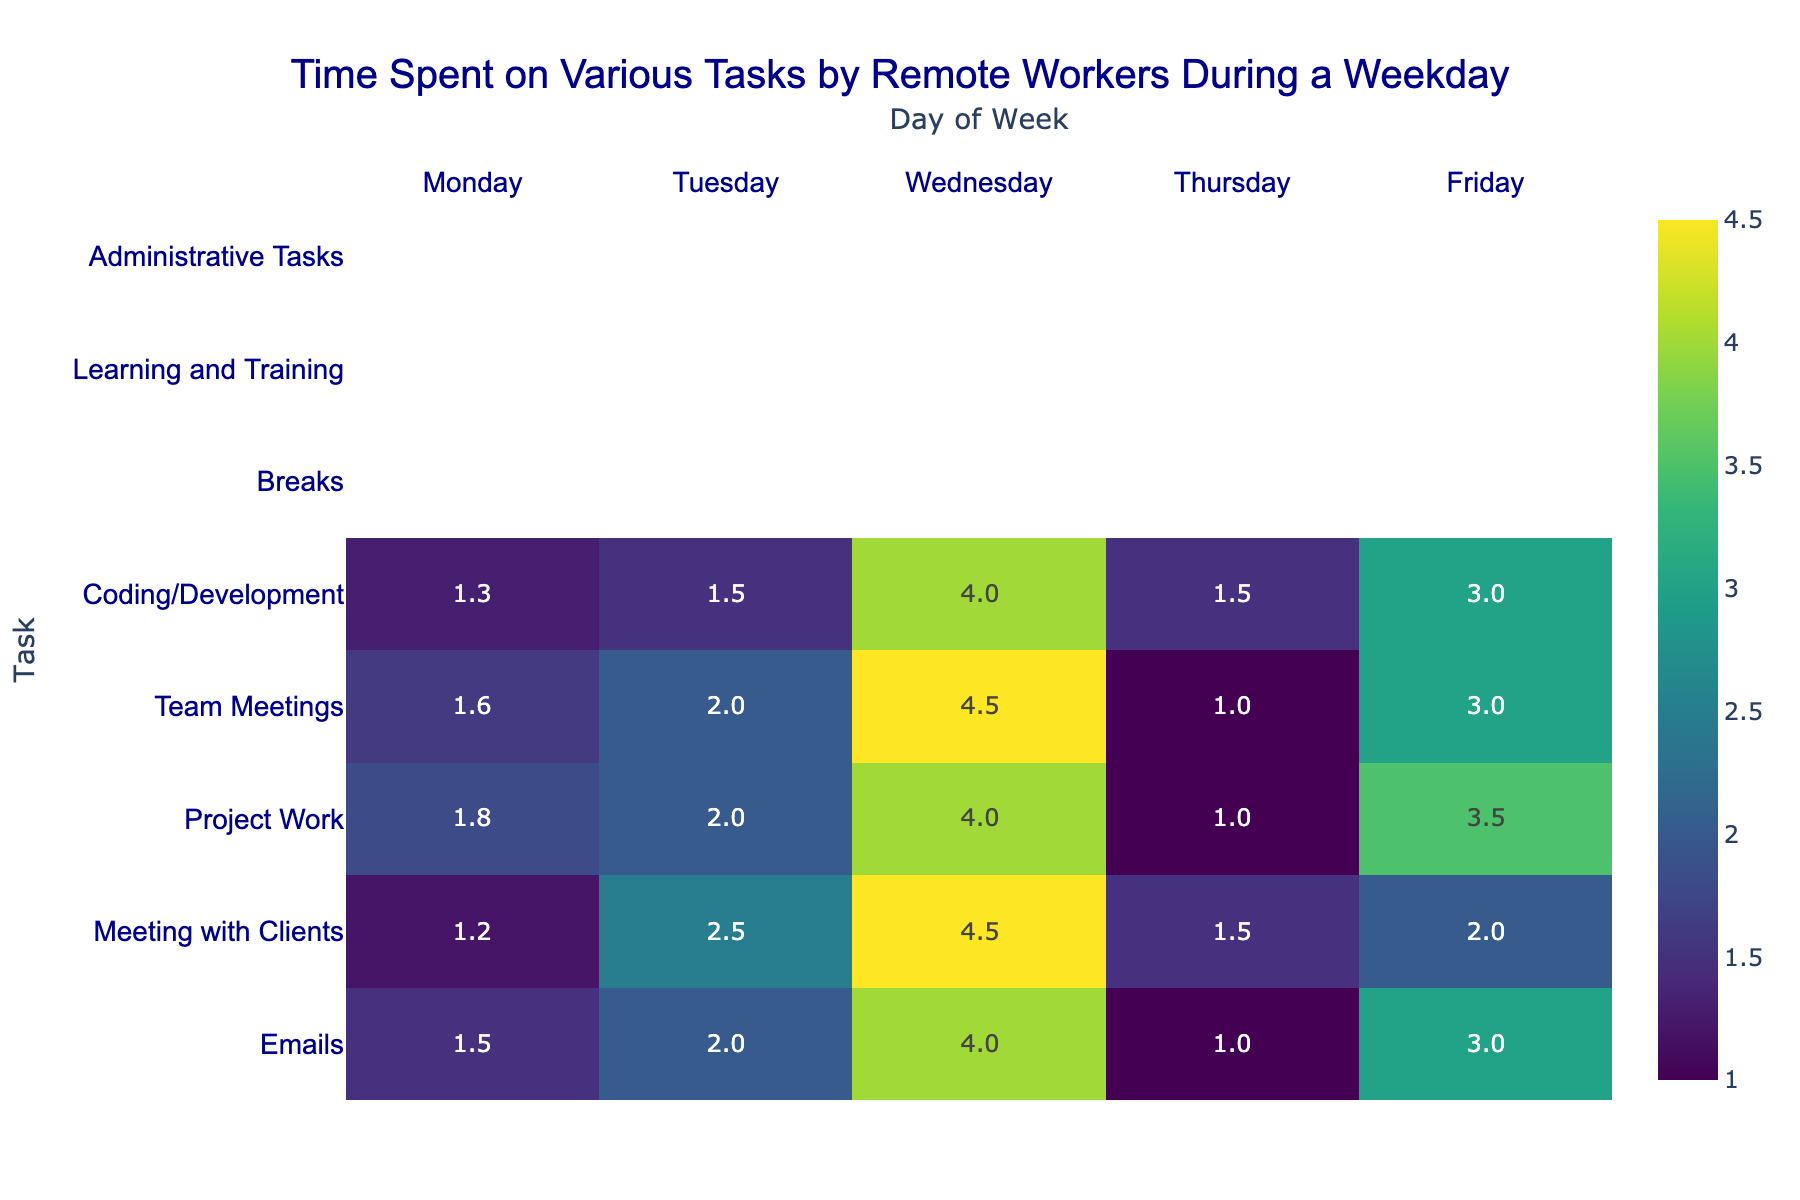What's the title of the heatmap? The title is usually displayed at the top center of the figure, and serves as a brief description of the chart.
Answer: Time Spent on Various Tasks by Remote Workers During a Weekday What is the range of time spent on "Emails" throughout the week? Look at the row corresponding to "Emails" and find the minimum and maximum values. The range spans from the smallest to the largest value.
Answer: 1.2 to 1.8 hours Which task takes up the most time on Wednesday? Identify the column for Wednesday and find the task corresponding to the highest value in that column.
Answer: Project Work On which day is the least amount of time spent on "Learning and Training"? Locate the row for "Learning and Training" and find the column with the smallest value.
Answer: Monday, Tuesday, Wednesday, Friday (0.5 hours) What is the average time spent on "Project Work" throughout the week? Add up all the values for "Project Work" and then divide by the number of days (5) to find the average.
Answer: 4.2 hours How much more time is spent on "Coding/Development" than "Emails" on Thursday? Subtract the time spent on "Emails" from the time spent on "Coding/Development" on Thursday.
Answer: 1.4 hours Which task has the most variation in time spent throughout the week? Identify the task with the largest difference between its maximum and minimum values by examining the range for each task row.
Answer: Meeting with Clients What is the total time spent on breaks from Monday to Friday? Add the values in the "Breaks" row for each day of the week to find the total.
Answer: 5.5 hours Are there any tasks that have a consistent amount of time spent across three or more days? Look for rows where at least three values are the same. Analyze and compare each task row across all days.
Answer: Breaks, Administrative Tasks (1.0 hours on multiple days) Which task has the least time allocated on Friday compared to other weekdays? Compare the Friday column values for each task to find the smallest value.
Answer: Administrative Tasks 